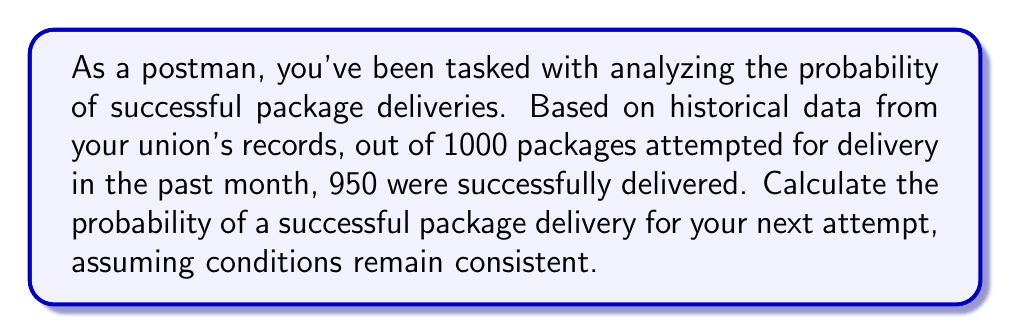Solve this math problem. To solve this inverse problem, we'll use the frequentist approach to probability:

1. Identify the total number of attempts:
   $n = 1000$

2. Identify the number of successful deliveries:
   $k = 950$

3. Calculate the probability of success using the formula:
   $$P(\text{success}) = \frac{\text{number of successful outcomes}}{\text{total number of attempts}}$$

4. Substitute the values:
   $$P(\text{success}) = \frac{k}{n} = \frac{950}{1000}$$

5. Simplify the fraction:
   $$P(\text{success}) = 0.95$$

6. Convert to a percentage (optional):
   $$P(\text{success}) = 0.95 \times 100\% = 95\%$$

Therefore, based on the historical data, the probability of a successful package delivery for your next attempt is 0.95 or 95%.
Answer: 0.95 